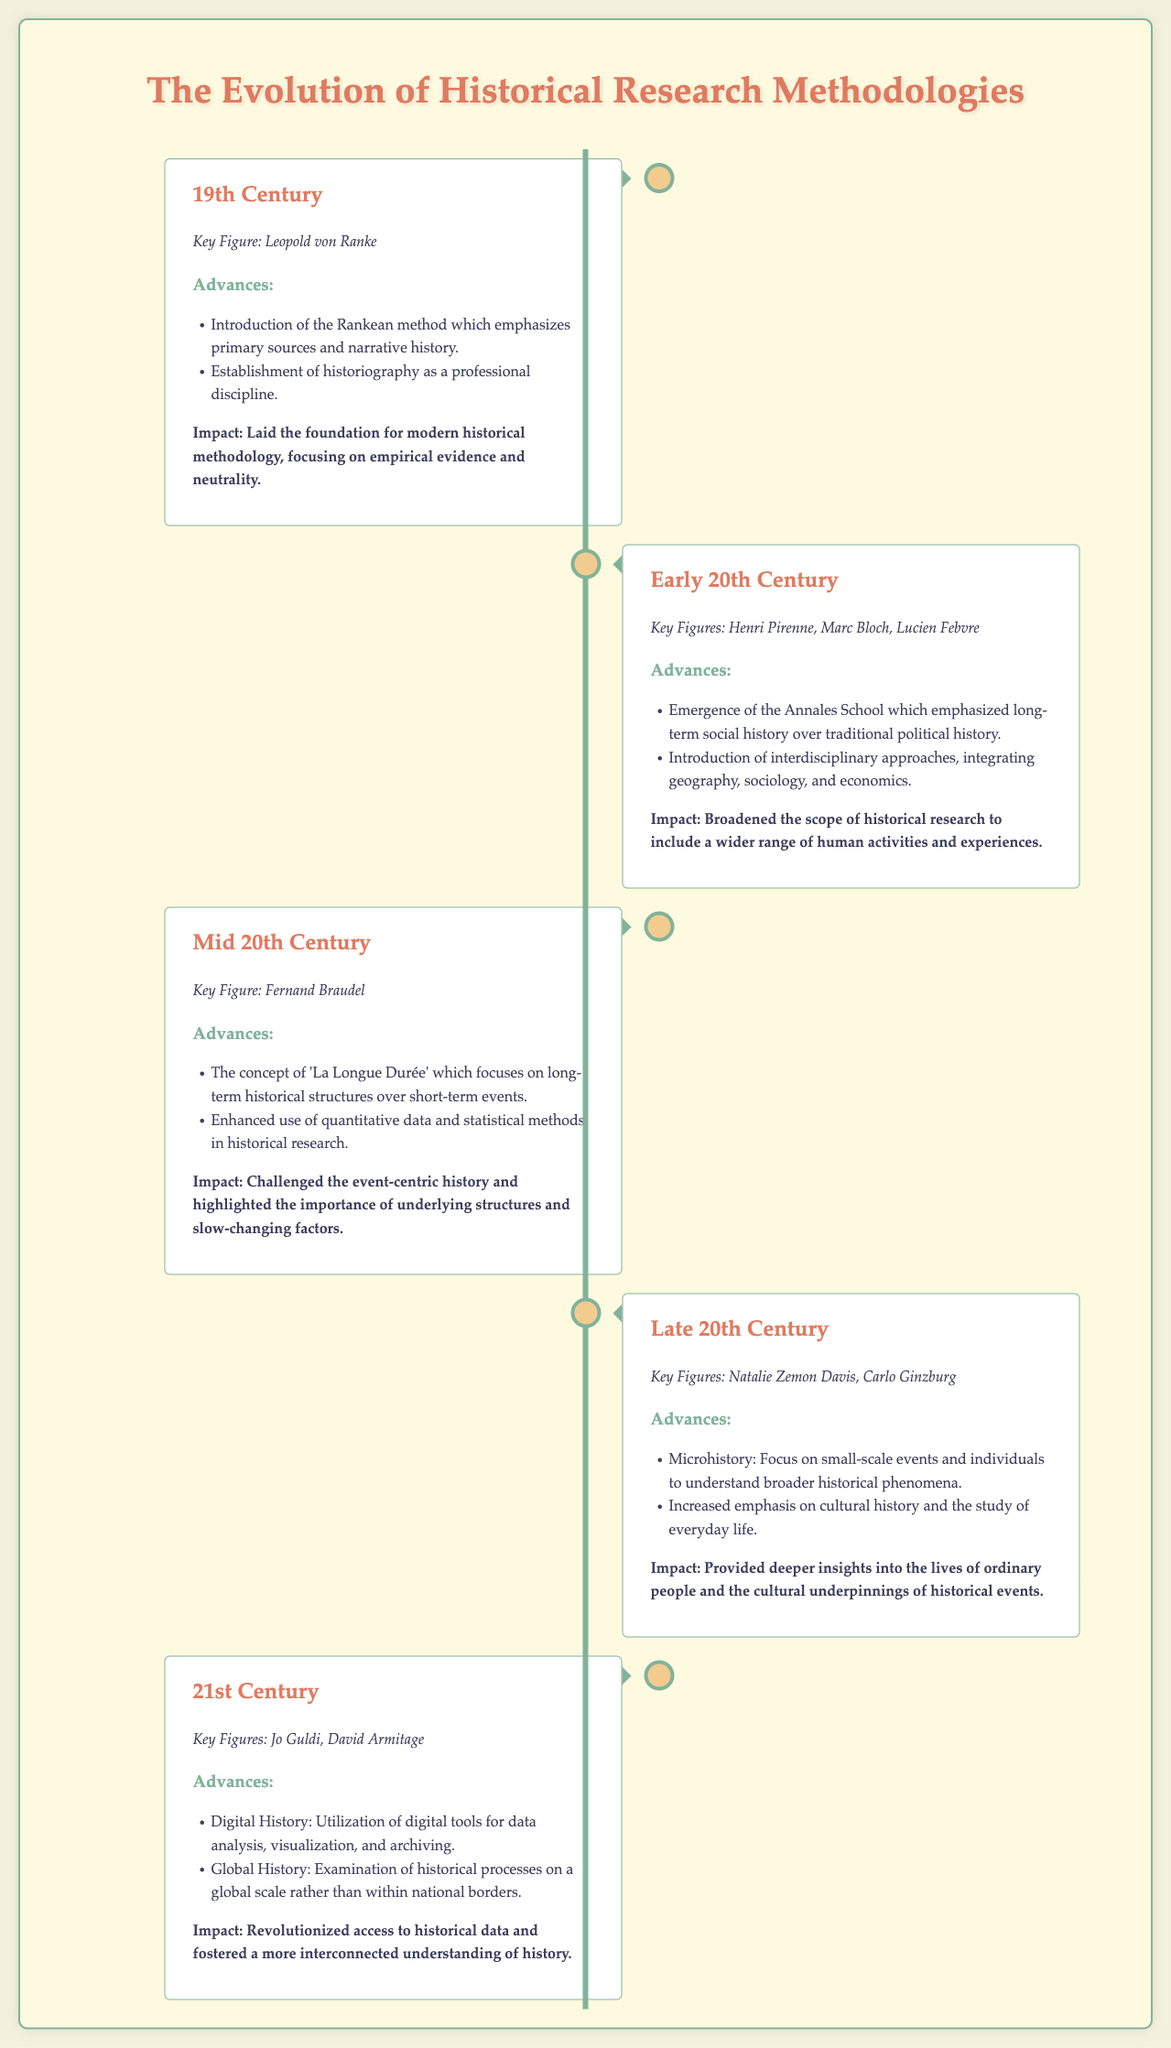What is a key figure from the 19th Century? The key figure in the 19th Century section is identified as Leopold von Ranke.
Answer: Leopold von Ranke What methodology was introduced in the 19th Century? The methodology introduced in the 19th Century is the Rankean method emphasizing primary sources.
Answer: Rankean method Which historical school emerged in the Early 20th Century? The Annales School emphasized long-term social history rather than traditional political history.
Answer: Annales School What concept did Fernand Braudel focus on in the Mid 20th Century? Fernand Braudel introduced the concept of 'La Longue Durée' focusing on long-term historical structures.
Answer: La Longue Durée Who are the key figures in the 21st Century? The key figures in the 21st Century are Jo Guldi and David Armitage.
Answer: Jo Guldi, David Armitage What major advancement is associated with the Late 20th Century? The advancement connected to the Late 20th Century is microhistory, focusing on small-scale events.
Answer: Microhistory What did the 21st Century advancement impact? The 21st Century advancements revolutionized access to historical data and fostered interconnected understanding.
Answer: Access to historical data Which two methodologies were emphasized in the Early 20th Century? The methodologies emphasized are interdisciplinary approaches integrating geography and sociology.
Answer: Interdisciplinary approaches What was the main impact of the Rankean method? The main impact of the Rankean method was the foundation for modern historical methodology based on empirical evidence.
Answer: Foundation for modern historical methodology 